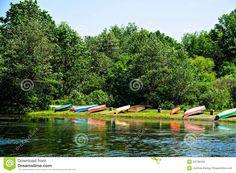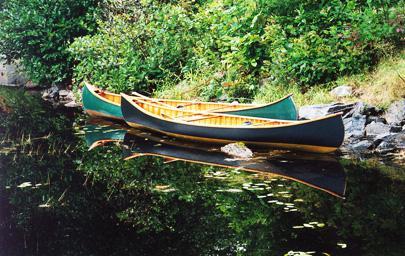The first image is the image on the left, the second image is the image on the right. Evaluate the accuracy of this statement regarding the images: "One of the images contains exactly two canoes.". Is it true? Answer yes or no. Yes. The first image is the image on the left, the second image is the image on the right. Analyze the images presented: Is the assertion "There are exactly two boats in the image on the right." valid? Answer yes or no. Yes. 